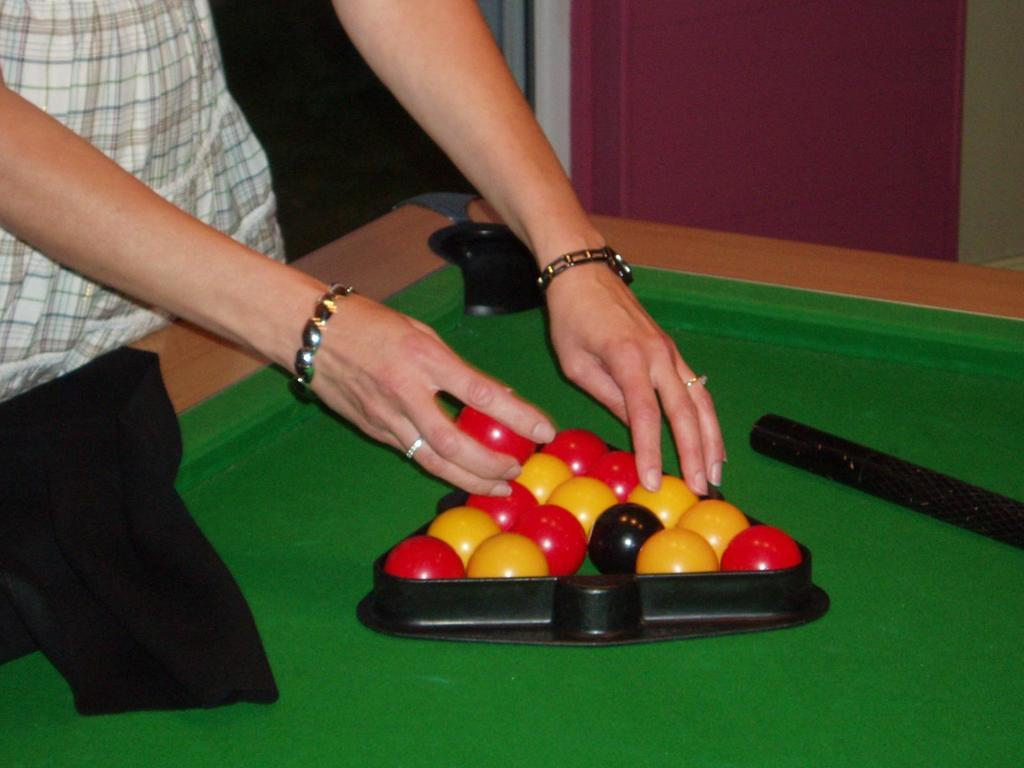What is the person's hands doing in the image? The person's hands are holding balls in the image. Where are the hands holding the balls located? The hands holding the balls are on a table. Can you describe any other objects present in the image? There are some objects present in the image, but their specific details are not mentioned in the provided facts. What type of zinc is present in the image? There is no zinc present in the image. Can you see any fairies in the image? There are no fairies present in the image. 